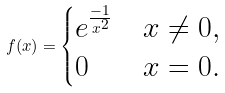<formula> <loc_0><loc_0><loc_500><loc_500>f ( x ) = \begin{cases} e ^ { \frac { - 1 } { x ^ { 2 } } } & x \ne 0 , \\ 0 & x = 0 . \end{cases}</formula> 